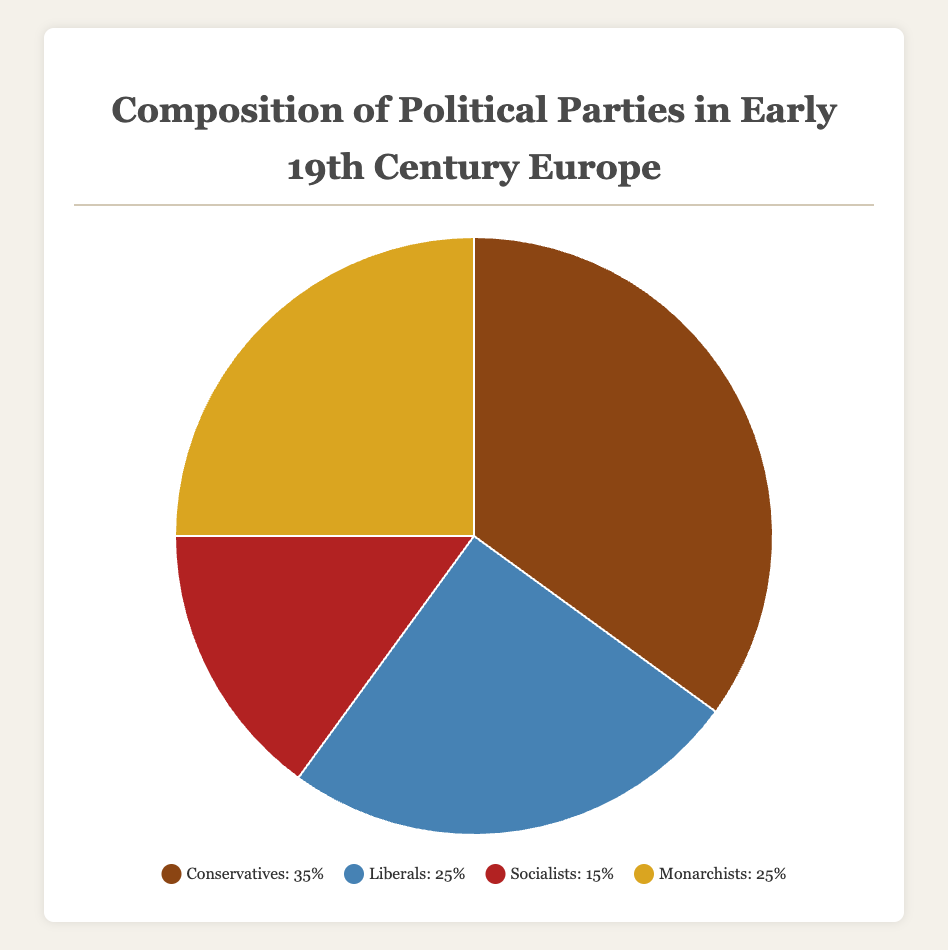What's the total percentage of Liberals and Monarchists combined? To find the total percentage of the Liberals and Monarchists, add their percentages: 25% (Liberals) + 25% (Monarchists) = 50%
Answer: 50% Which party has the lowest representation in the chart? By looking at the chart, the Socialists have the lowest percentage at 15%.
Answer: Socialists Are Conservatives more than double the proportion of Socialists? Conservatives have 35%, while Socialists have 15%. Double the Socialists’ percentage is 30% (2 x 15%), and Conservatives' percentage (35%) is more than 30%.
Answer: Yes Which party has the same percentage as the Monarchists? The Liberals and the Monarchists both have the same percentage of 25%.
Answer: Liberals What is the difference in percentage between the party with the largest representation and the party with the smallest representation? The Conservatives have the largest percentage at 35%, and the Socialists have the lowest percentage at 15%. The difference is 35% - 15% = 20%.
Answer: 20% What is the average representation percentage of all the parties? The sum of the percentages of all parties is 35% (Conservatives) + 25% (Liberals) + 15% (Socialists) + 25% (Monarchists) = 100%. Since there are 4 parties, the average is 100% / 4 = 25%.
Answer: 25% Which sections of the pie chart would be represented using different shades of brown? This answer uses the visual attributes: the sections for Conservatives and Monarchists are shown in different shades of brown.
Answer: Conservatives and Monarchists How much higher is the representation of Conservatives compared to Liberals? The percentage of Conservatives is 35%, while the percentage of Liberals is 25%. The difference between them is 35% - 25% = 10%.
Answer: 10% 